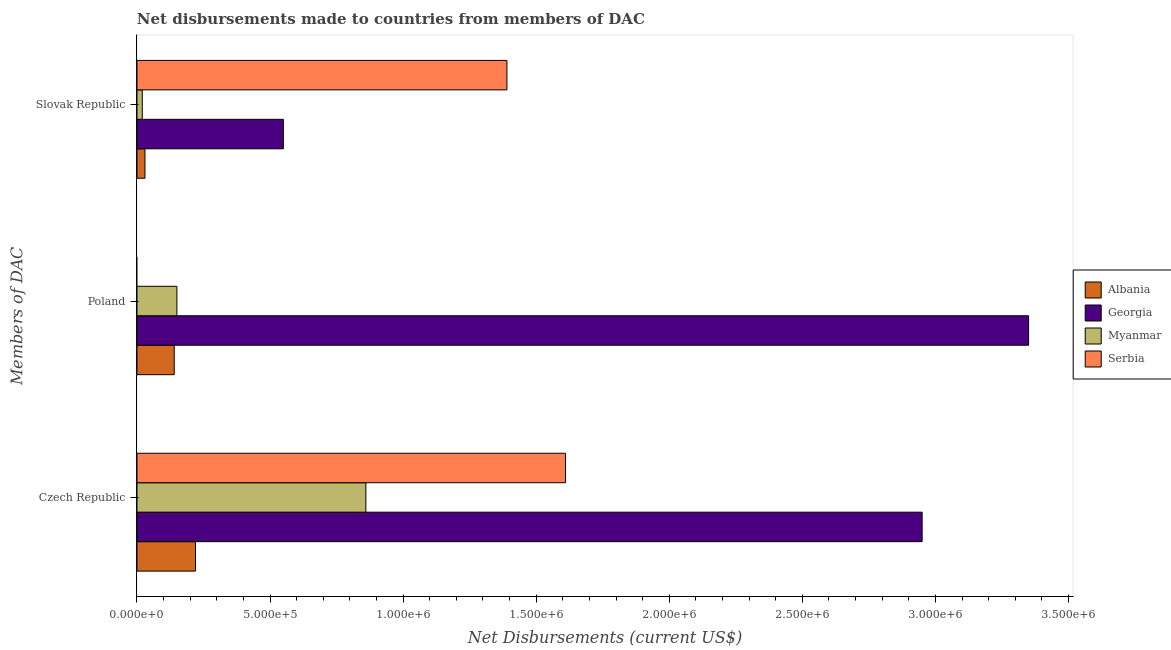How many groups of bars are there?
Your response must be concise. 3. Are the number of bars on each tick of the Y-axis equal?
Provide a short and direct response. No. How many bars are there on the 2nd tick from the top?
Offer a terse response. 3. What is the label of the 2nd group of bars from the top?
Provide a short and direct response. Poland. What is the net disbursements made by poland in Serbia?
Keep it short and to the point. 0. Across all countries, what is the maximum net disbursements made by czech republic?
Ensure brevity in your answer.  2.95e+06. Across all countries, what is the minimum net disbursements made by poland?
Your answer should be very brief. 0. In which country was the net disbursements made by slovak republic maximum?
Your answer should be very brief. Serbia. What is the total net disbursements made by poland in the graph?
Provide a succinct answer. 3.64e+06. What is the difference between the net disbursements made by slovak republic in Myanmar and that in Albania?
Make the answer very short. -10000. What is the difference between the net disbursements made by poland in Georgia and the net disbursements made by slovak republic in Myanmar?
Your response must be concise. 3.33e+06. What is the average net disbursements made by czech republic per country?
Your answer should be very brief. 1.41e+06. What is the difference between the net disbursements made by slovak republic and net disbursements made by poland in Georgia?
Your answer should be compact. -2.80e+06. What is the ratio of the net disbursements made by czech republic in Myanmar to that in Georgia?
Your answer should be very brief. 0.29. Is the difference between the net disbursements made by slovak republic in Georgia and Myanmar greater than the difference between the net disbursements made by czech republic in Georgia and Myanmar?
Make the answer very short. No. What is the difference between the highest and the second highest net disbursements made by poland?
Your answer should be compact. 3.20e+06. What is the difference between the highest and the lowest net disbursements made by czech republic?
Provide a succinct answer. 2.73e+06. In how many countries, is the net disbursements made by czech republic greater than the average net disbursements made by czech republic taken over all countries?
Offer a very short reply. 2. Is it the case that in every country, the sum of the net disbursements made by czech republic and net disbursements made by poland is greater than the net disbursements made by slovak republic?
Keep it short and to the point. Yes. How many bars are there?
Ensure brevity in your answer.  11. Are all the bars in the graph horizontal?
Ensure brevity in your answer.  Yes. What is the difference between two consecutive major ticks on the X-axis?
Keep it short and to the point. 5.00e+05. Where does the legend appear in the graph?
Provide a short and direct response. Center right. How many legend labels are there?
Provide a short and direct response. 4. What is the title of the graph?
Your response must be concise. Net disbursements made to countries from members of DAC. What is the label or title of the X-axis?
Offer a very short reply. Net Disbursements (current US$). What is the label or title of the Y-axis?
Your answer should be compact. Members of DAC. What is the Net Disbursements (current US$) of Georgia in Czech Republic?
Your answer should be compact. 2.95e+06. What is the Net Disbursements (current US$) of Myanmar in Czech Republic?
Ensure brevity in your answer.  8.60e+05. What is the Net Disbursements (current US$) of Serbia in Czech Republic?
Provide a succinct answer. 1.61e+06. What is the Net Disbursements (current US$) of Albania in Poland?
Your answer should be very brief. 1.40e+05. What is the Net Disbursements (current US$) of Georgia in Poland?
Keep it short and to the point. 3.35e+06. What is the Net Disbursements (current US$) in Myanmar in Poland?
Your answer should be very brief. 1.50e+05. What is the Net Disbursements (current US$) in Albania in Slovak Republic?
Provide a short and direct response. 3.00e+04. What is the Net Disbursements (current US$) of Myanmar in Slovak Republic?
Your response must be concise. 2.00e+04. What is the Net Disbursements (current US$) of Serbia in Slovak Republic?
Your answer should be very brief. 1.39e+06. Across all Members of DAC, what is the maximum Net Disbursements (current US$) of Georgia?
Ensure brevity in your answer.  3.35e+06. Across all Members of DAC, what is the maximum Net Disbursements (current US$) in Myanmar?
Keep it short and to the point. 8.60e+05. Across all Members of DAC, what is the maximum Net Disbursements (current US$) of Serbia?
Your response must be concise. 1.61e+06. Across all Members of DAC, what is the minimum Net Disbursements (current US$) in Albania?
Offer a terse response. 3.00e+04. Across all Members of DAC, what is the minimum Net Disbursements (current US$) in Serbia?
Your answer should be compact. 0. What is the total Net Disbursements (current US$) in Georgia in the graph?
Your response must be concise. 6.85e+06. What is the total Net Disbursements (current US$) of Myanmar in the graph?
Make the answer very short. 1.03e+06. What is the total Net Disbursements (current US$) in Serbia in the graph?
Make the answer very short. 3.00e+06. What is the difference between the Net Disbursements (current US$) in Albania in Czech Republic and that in Poland?
Your answer should be compact. 8.00e+04. What is the difference between the Net Disbursements (current US$) in Georgia in Czech Republic and that in Poland?
Your response must be concise. -4.00e+05. What is the difference between the Net Disbursements (current US$) in Myanmar in Czech Republic and that in Poland?
Your response must be concise. 7.10e+05. What is the difference between the Net Disbursements (current US$) in Albania in Czech Republic and that in Slovak Republic?
Your answer should be compact. 1.90e+05. What is the difference between the Net Disbursements (current US$) in Georgia in Czech Republic and that in Slovak Republic?
Your response must be concise. 2.40e+06. What is the difference between the Net Disbursements (current US$) in Myanmar in Czech Republic and that in Slovak Republic?
Keep it short and to the point. 8.40e+05. What is the difference between the Net Disbursements (current US$) in Serbia in Czech Republic and that in Slovak Republic?
Give a very brief answer. 2.20e+05. What is the difference between the Net Disbursements (current US$) in Georgia in Poland and that in Slovak Republic?
Your answer should be very brief. 2.80e+06. What is the difference between the Net Disbursements (current US$) of Albania in Czech Republic and the Net Disbursements (current US$) of Georgia in Poland?
Provide a succinct answer. -3.13e+06. What is the difference between the Net Disbursements (current US$) of Albania in Czech Republic and the Net Disbursements (current US$) of Myanmar in Poland?
Make the answer very short. 7.00e+04. What is the difference between the Net Disbursements (current US$) in Georgia in Czech Republic and the Net Disbursements (current US$) in Myanmar in Poland?
Offer a very short reply. 2.80e+06. What is the difference between the Net Disbursements (current US$) in Albania in Czech Republic and the Net Disbursements (current US$) in Georgia in Slovak Republic?
Offer a very short reply. -3.30e+05. What is the difference between the Net Disbursements (current US$) of Albania in Czech Republic and the Net Disbursements (current US$) of Serbia in Slovak Republic?
Offer a terse response. -1.17e+06. What is the difference between the Net Disbursements (current US$) in Georgia in Czech Republic and the Net Disbursements (current US$) in Myanmar in Slovak Republic?
Your response must be concise. 2.93e+06. What is the difference between the Net Disbursements (current US$) of Georgia in Czech Republic and the Net Disbursements (current US$) of Serbia in Slovak Republic?
Provide a succinct answer. 1.56e+06. What is the difference between the Net Disbursements (current US$) of Myanmar in Czech Republic and the Net Disbursements (current US$) of Serbia in Slovak Republic?
Keep it short and to the point. -5.30e+05. What is the difference between the Net Disbursements (current US$) of Albania in Poland and the Net Disbursements (current US$) of Georgia in Slovak Republic?
Provide a short and direct response. -4.10e+05. What is the difference between the Net Disbursements (current US$) in Albania in Poland and the Net Disbursements (current US$) in Myanmar in Slovak Republic?
Your answer should be compact. 1.20e+05. What is the difference between the Net Disbursements (current US$) of Albania in Poland and the Net Disbursements (current US$) of Serbia in Slovak Republic?
Provide a short and direct response. -1.25e+06. What is the difference between the Net Disbursements (current US$) in Georgia in Poland and the Net Disbursements (current US$) in Myanmar in Slovak Republic?
Your answer should be compact. 3.33e+06. What is the difference between the Net Disbursements (current US$) in Georgia in Poland and the Net Disbursements (current US$) in Serbia in Slovak Republic?
Give a very brief answer. 1.96e+06. What is the difference between the Net Disbursements (current US$) of Myanmar in Poland and the Net Disbursements (current US$) of Serbia in Slovak Republic?
Keep it short and to the point. -1.24e+06. What is the average Net Disbursements (current US$) of Albania per Members of DAC?
Offer a very short reply. 1.30e+05. What is the average Net Disbursements (current US$) in Georgia per Members of DAC?
Offer a terse response. 2.28e+06. What is the average Net Disbursements (current US$) in Myanmar per Members of DAC?
Provide a short and direct response. 3.43e+05. What is the average Net Disbursements (current US$) of Serbia per Members of DAC?
Offer a very short reply. 1.00e+06. What is the difference between the Net Disbursements (current US$) of Albania and Net Disbursements (current US$) of Georgia in Czech Republic?
Make the answer very short. -2.73e+06. What is the difference between the Net Disbursements (current US$) in Albania and Net Disbursements (current US$) in Myanmar in Czech Republic?
Ensure brevity in your answer.  -6.40e+05. What is the difference between the Net Disbursements (current US$) in Albania and Net Disbursements (current US$) in Serbia in Czech Republic?
Your response must be concise. -1.39e+06. What is the difference between the Net Disbursements (current US$) of Georgia and Net Disbursements (current US$) of Myanmar in Czech Republic?
Ensure brevity in your answer.  2.09e+06. What is the difference between the Net Disbursements (current US$) of Georgia and Net Disbursements (current US$) of Serbia in Czech Republic?
Give a very brief answer. 1.34e+06. What is the difference between the Net Disbursements (current US$) of Myanmar and Net Disbursements (current US$) of Serbia in Czech Republic?
Make the answer very short. -7.50e+05. What is the difference between the Net Disbursements (current US$) in Albania and Net Disbursements (current US$) in Georgia in Poland?
Offer a very short reply. -3.21e+06. What is the difference between the Net Disbursements (current US$) in Georgia and Net Disbursements (current US$) in Myanmar in Poland?
Provide a succinct answer. 3.20e+06. What is the difference between the Net Disbursements (current US$) in Albania and Net Disbursements (current US$) in Georgia in Slovak Republic?
Offer a terse response. -5.20e+05. What is the difference between the Net Disbursements (current US$) in Albania and Net Disbursements (current US$) in Serbia in Slovak Republic?
Your answer should be compact. -1.36e+06. What is the difference between the Net Disbursements (current US$) in Georgia and Net Disbursements (current US$) in Myanmar in Slovak Republic?
Keep it short and to the point. 5.30e+05. What is the difference between the Net Disbursements (current US$) in Georgia and Net Disbursements (current US$) in Serbia in Slovak Republic?
Offer a very short reply. -8.40e+05. What is the difference between the Net Disbursements (current US$) in Myanmar and Net Disbursements (current US$) in Serbia in Slovak Republic?
Ensure brevity in your answer.  -1.37e+06. What is the ratio of the Net Disbursements (current US$) in Albania in Czech Republic to that in Poland?
Provide a succinct answer. 1.57. What is the ratio of the Net Disbursements (current US$) in Georgia in Czech Republic to that in Poland?
Keep it short and to the point. 0.88. What is the ratio of the Net Disbursements (current US$) in Myanmar in Czech Republic to that in Poland?
Provide a succinct answer. 5.73. What is the ratio of the Net Disbursements (current US$) in Albania in Czech Republic to that in Slovak Republic?
Provide a short and direct response. 7.33. What is the ratio of the Net Disbursements (current US$) in Georgia in Czech Republic to that in Slovak Republic?
Your answer should be compact. 5.36. What is the ratio of the Net Disbursements (current US$) of Serbia in Czech Republic to that in Slovak Republic?
Provide a short and direct response. 1.16. What is the ratio of the Net Disbursements (current US$) in Albania in Poland to that in Slovak Republic?
Your answer should be very brief. 4.67. What is the ratio of the Net Disbursements (current US$) in Georgia in Poland to that in Slovak Republic?
Provide a short and direct response. 6.09. What is the ratio of the Net Disbursements (current US$) in Myanmar in Poland to that in Slovak Republic?
Keep it short and to the point. 7.5. What is the difference between the highest and the second highest Net Disbursements (current US$) in Myanmar?
Give a very brief answer. 7.10e+05. What is the difference between the highest and the lowest Net Disbursements (current US$) of Georgia?
Offer a terse response. 2.80e+06. What is the difference between the highest and the lowest Net Disbursements (current US$) of Myanmar?
Provide a succinct answer. 8.40e+05. What is the difference between the highest and the lowest Net Disbursements (current US$) in Serbia?
Give a very brief answer. 1.61e+06. 